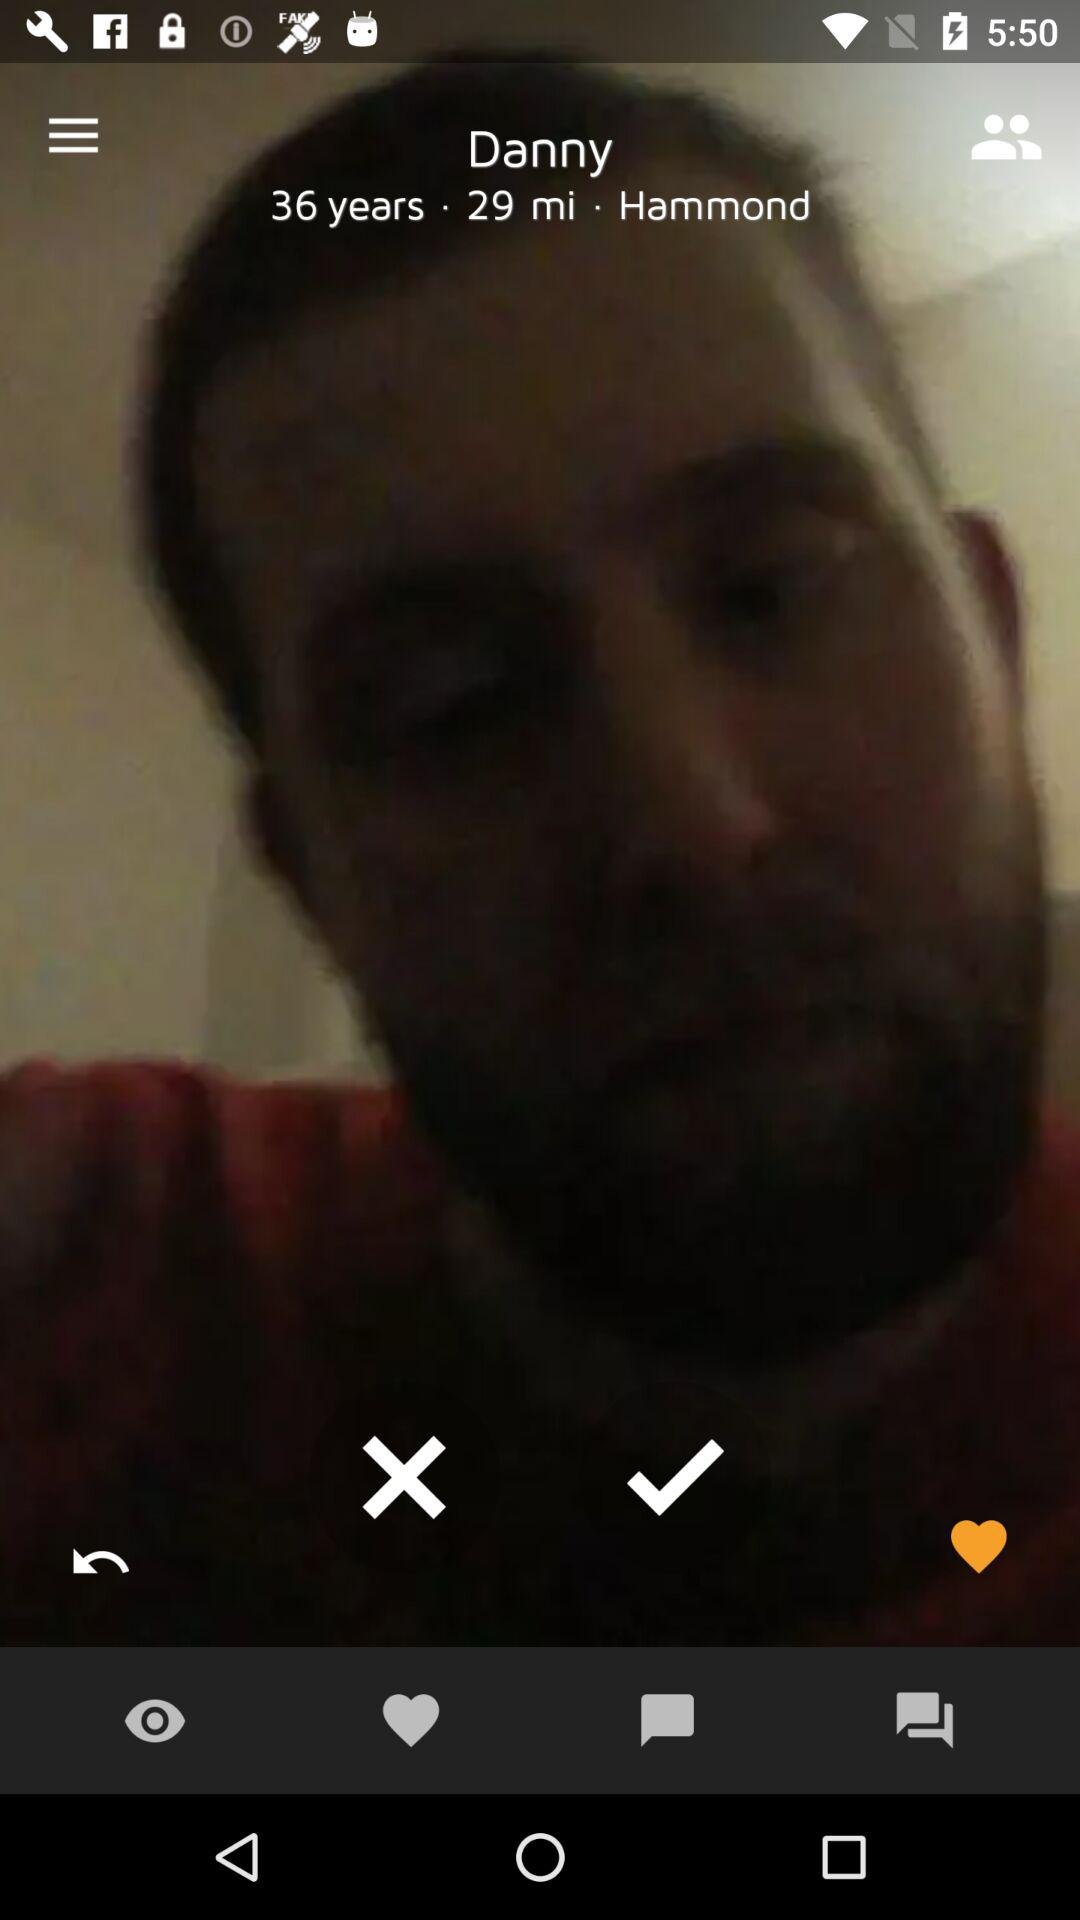What is the user name? The user name is Danny. 